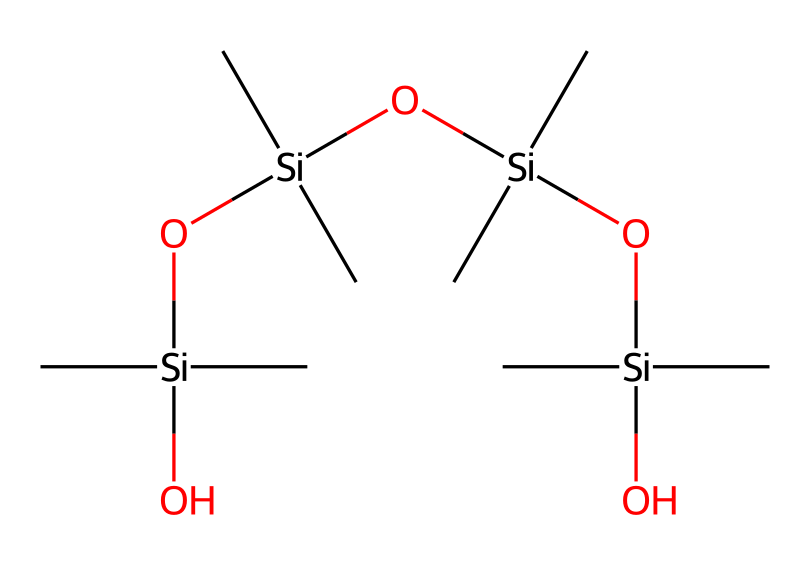what is the central atom in this chemical structure? The chemical structure features silicon atoms as the primary element, surrounded by various functional groups. The SMILES notation indicates that the central atoms are silicon.
Answer: silicon how many silicon atoms are present in this compound? Analyzing the SMILES representation, we can count a total of four silicon atoms (each represented by 'Si'). There are four occurrences of 'Si' in the structure.
Answer: four what type of functional group is present in this compound? In this structure, the hydroxyl groups (–OH) are evident, suggesting the presence of a silanol functional group. The branching and structure indicate siloxane characteristics due to the –O–Si– bonds.
Answer: silanol how many oxygen atoms are present in this chemical structure? By carefully examining the SMILES notation, we can identify the presence of three oxygen atoms in the structure as each 'O' represents an oxygen atom.
Answer: three which characteristic of this compound makes it suitable as a sealant? The presence of silicon-oxygen bonds (siloxane connections) in the structure provides flexibility and durability, making it ideal for sealant applications. This feature contributes to its water resistance and adhesion properties.
Answer: siloxane connections what role do the methyl groups play in the stability of this compound? The presence of methyl groups (–CH3) contributes to the stability and hydrophobic properties of the compound. They help to enhance the chemical's resistance to weathering and moisture, which is essential for sealants used outdoors.
Answer: hydrophobic properties how is this compound classified based on its structure? Based on the predominance of silicon and oxygen atoms linked by siloxane bonds, this compound is classified as an organosilicon compound. This classification indicates its application in various silicone technologies.
Answer: organosilicon compound 